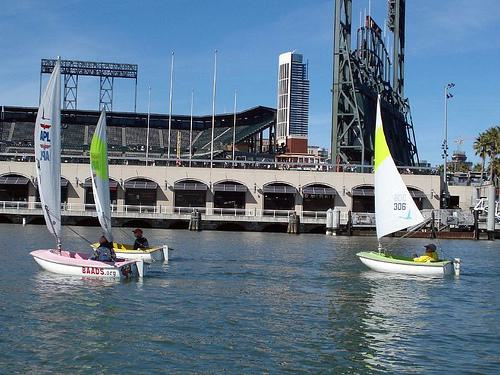Can you tell me what the building in the background is? The building in the background with noticeable arches appears to be a stadium, characterized by its large structure along the waterfront and the multiple entry archways visible from this perspective. 